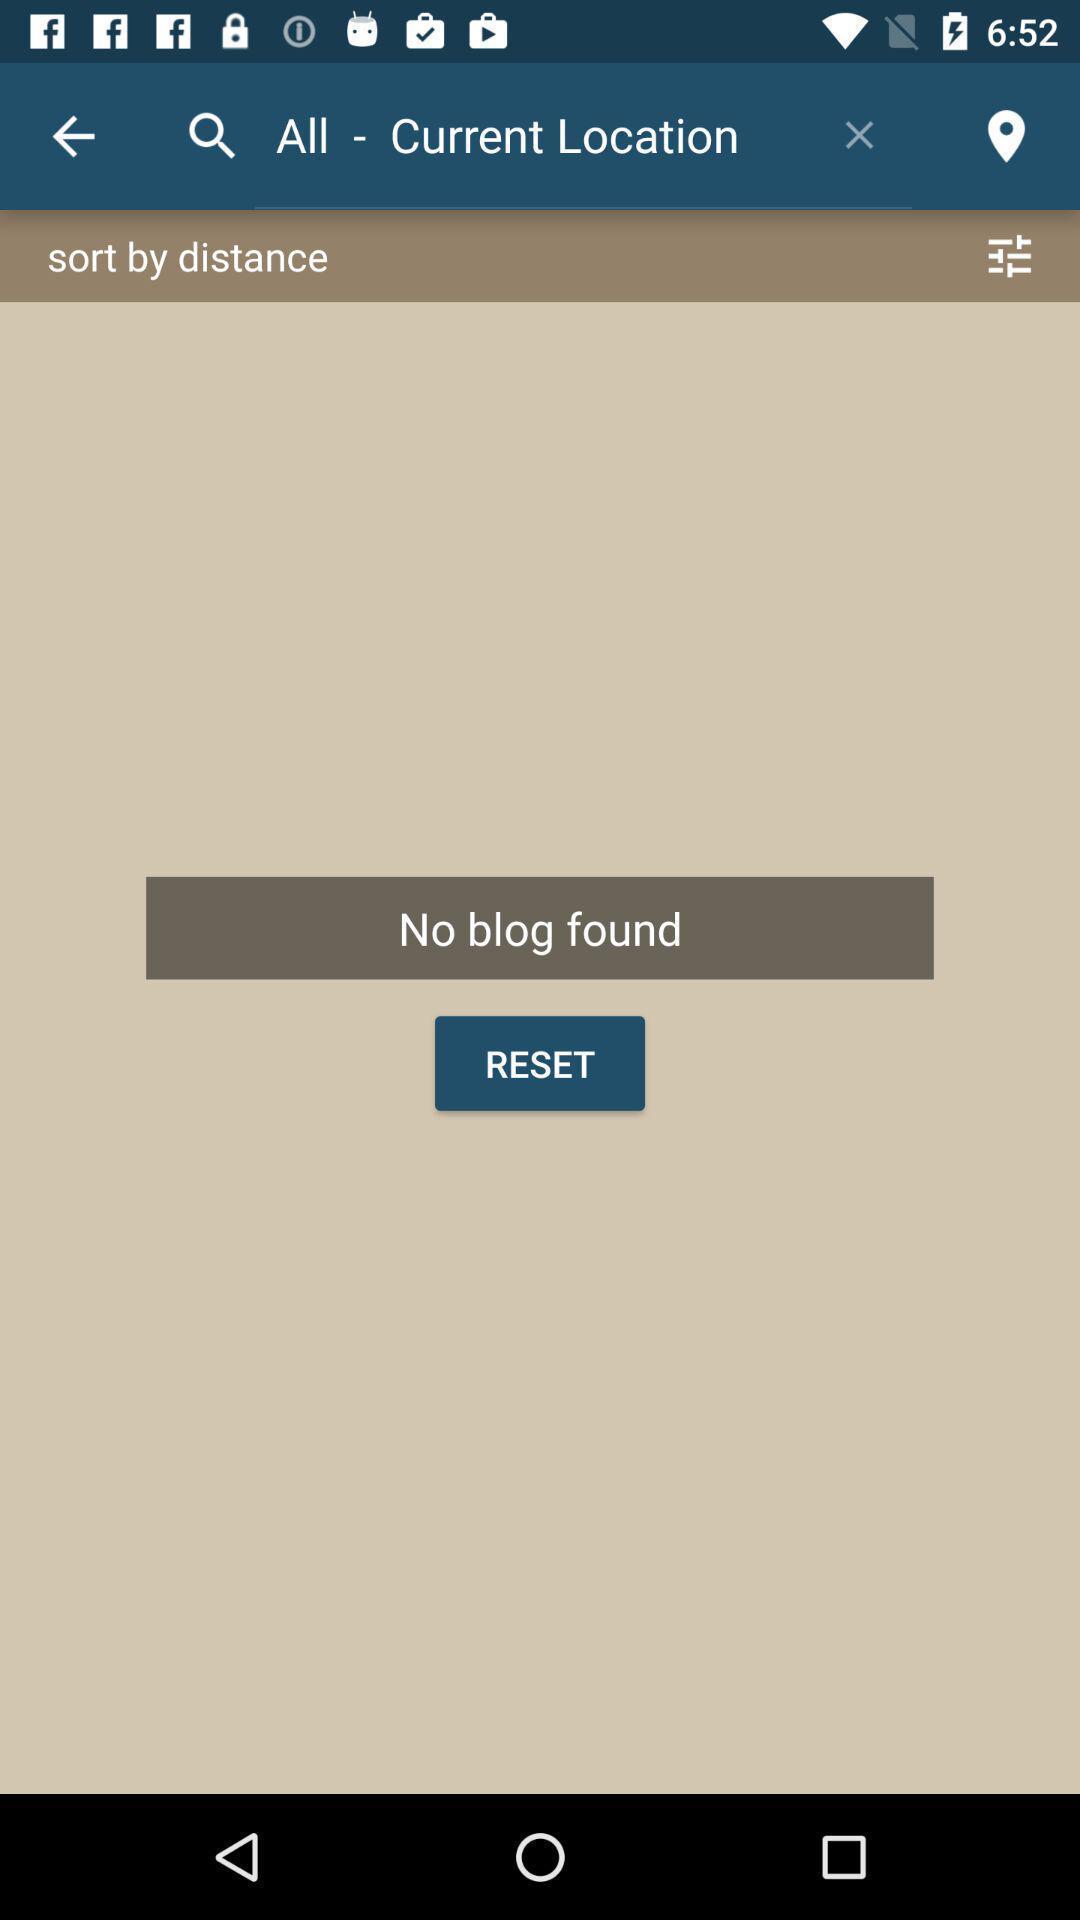What is the overall content of this screenshot? Search result in a blogging application. 